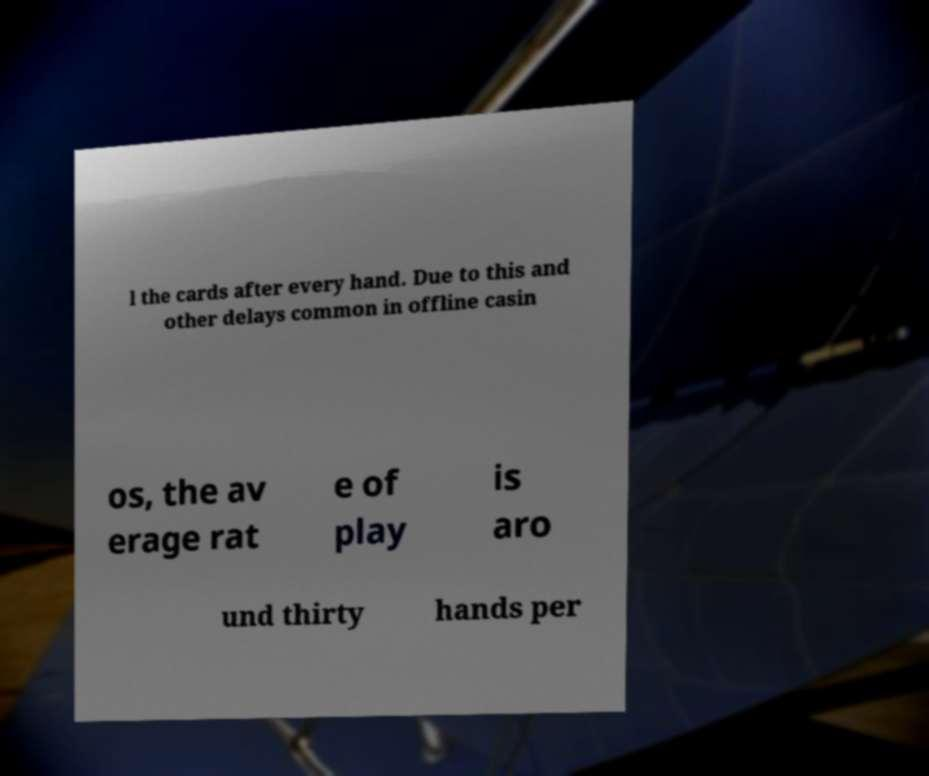Can you read and provide the text displayed in the image?This photo seems to have some interesting text. Can you extract and type it out for me? l the cards after every hand. Due to this and other delays common in offline casin os, the av erage rat e of play is aro und thirty hands per 